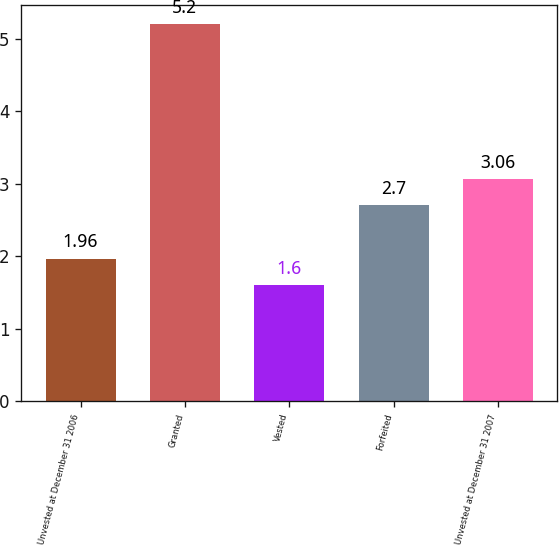Convert chart to OTSL. <chart><loc_0><loc_0><loc_500><loc_500><bar_chart><fcel>Unvested at December 31 2006<fcel>Granted<fcel>Vested<fcel>Forfeited<fcel>Unvested at December 31 2007<nl><fcel>1.96<fcel>5.2<fcel>1.6<fcel>2.7<fcel>3.06<nl></chart> 